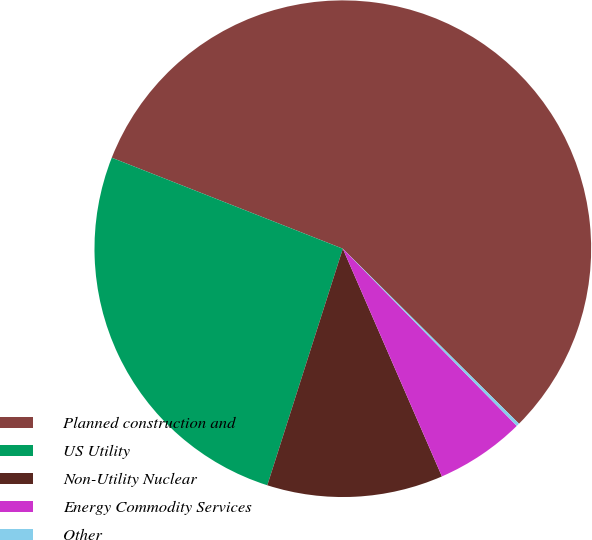<chart> <loc_0><loc_0><loc_500><loc_500><pie_chart><fcel>Planned construction and<fcel>US Utility<fcel>Non-Utility Nuclear<fcel>Energy Commodity Services<fcel>Other<nl><fcel>56.47%<fcel>26.05%<fcel>11.45%<fcel>5.82%<fcel>0.2%<nl></chart> 